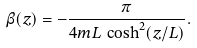Convert formula to latex. <formula><loc_0><loc_0><loc_500><loc_500>\beta ( z ) = - \frac { \pi } { 4 m L \, \cosh ^ { 2 } ( z / L ) } .</formula> 